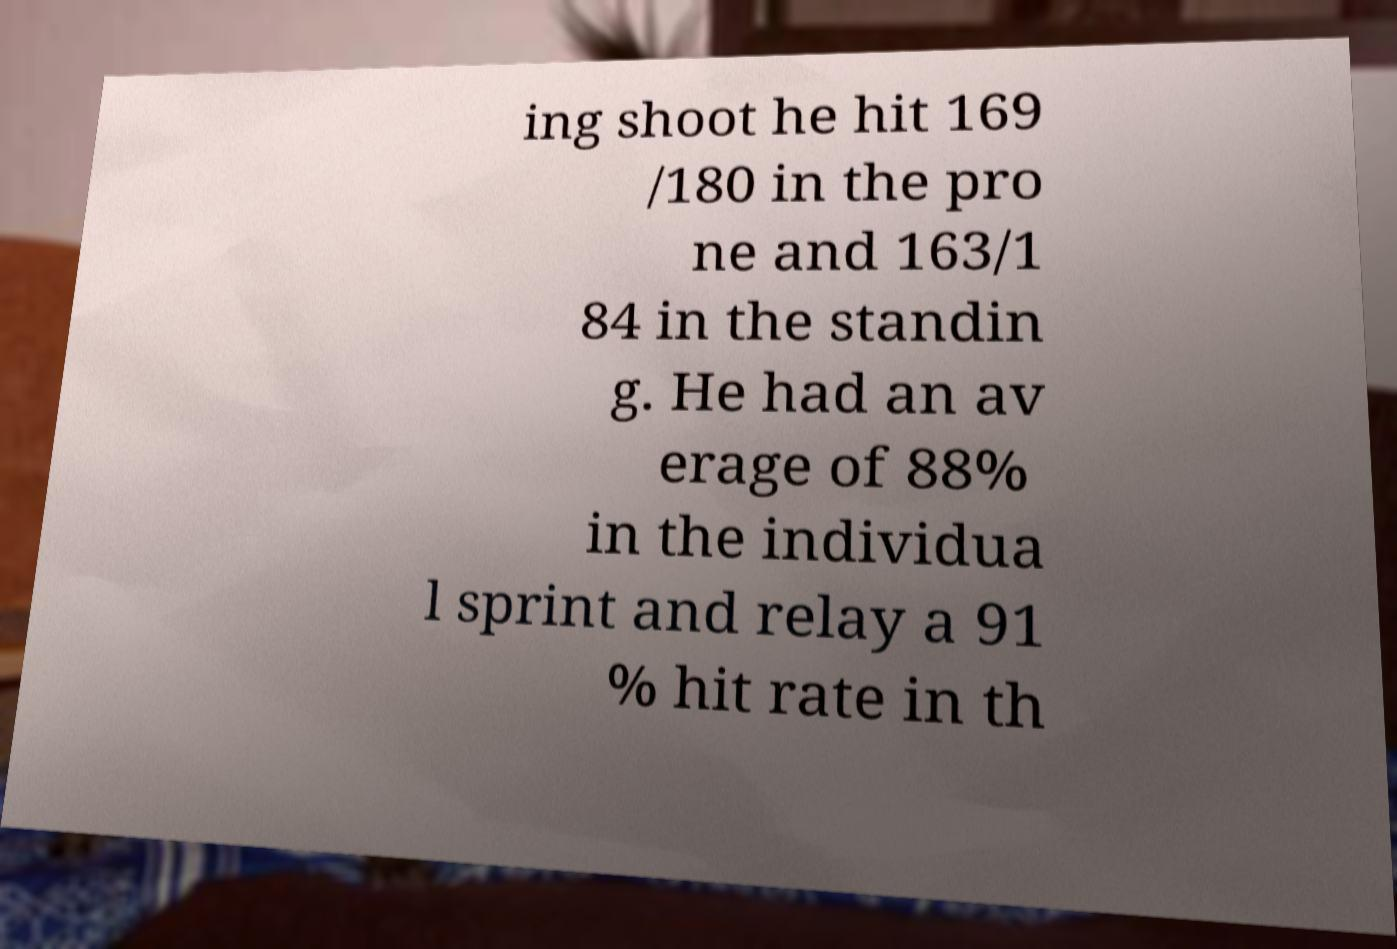Can you read and provide the text displayed in the image?This photo seems to have some interesting text. Can you extract and type it out for me? ing shoot he hit 169 /180 in the pro ne and 163/1 84 in the standin g. He had an av erage of 88% in the individua l sprint and relay a 91 % hit rate in th 